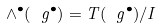Convert formula to latex. <formula><loc_0><loc_0><loc_500><loc_500>\wedge ^ { \bullet } ( \ g ^ { \bullet } ) = T ( \ g ^ { \bullet } ) / I</formula> 